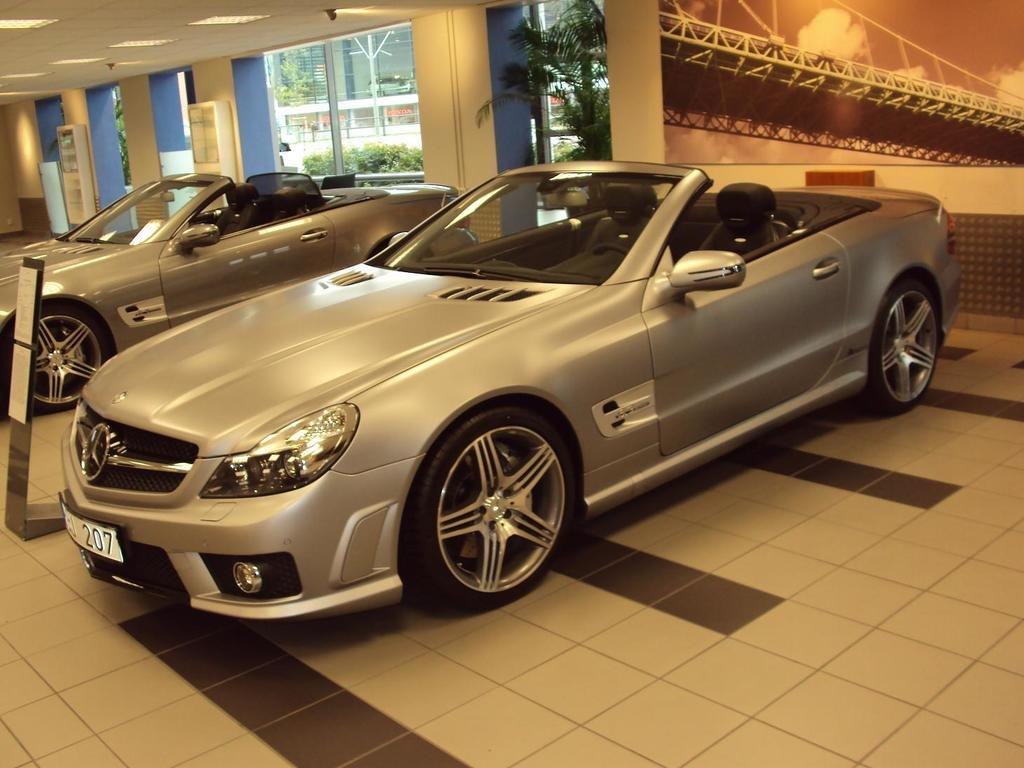How many cars are in the image? There are two cars in the image. What can be seen in the background of the image? There is a poster on a wall, lights, poles, and trees visible in the background. What type of objects are present in the background that are made of metal? Metal rods are present in the background. Can you see any giants walking around in the image? There are no giants present in the image. What type of toad can be seen sitting on the hood of one of the cars? There is no toad visible in the image. 